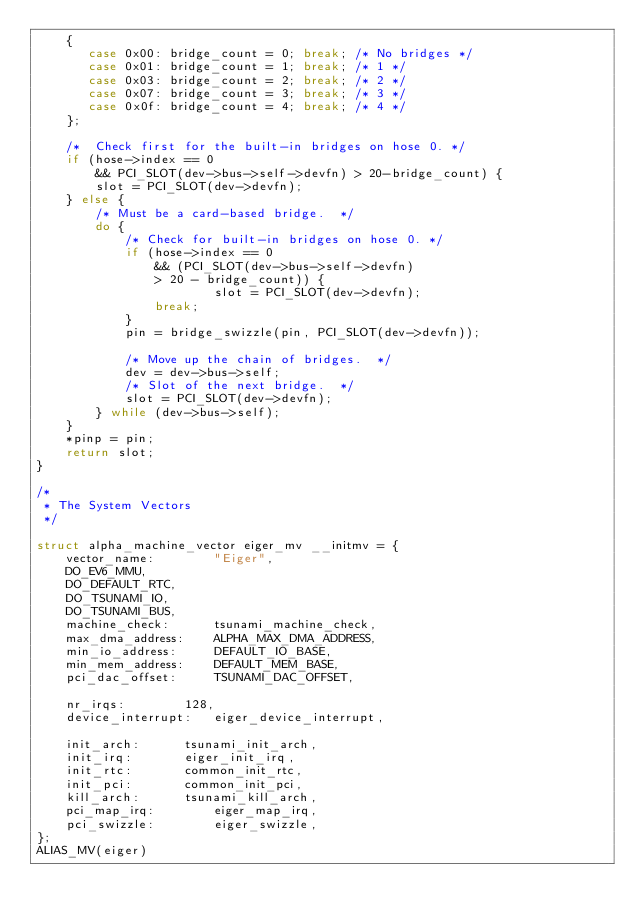Convert code to text. <code><loc_0><loc_0><loc_500><loc_500><_C_>	{
	   case 0x00: bridge_count = 0; break; /* No bridges */
	   case 0x01: bridge_count = 1; break; /* 1 */
	   case 0x03: bridge_count = 2; break; /* 2 */
	   case 0x07: bridge_count = 3; break; /* 3 */
	   case 0x0f: bridge_count = 4; break; /* 4 */
	};

	/*  Check first for the built-in bridges on hose 0. */
	if (hose->index == 0
	    && PCI_SLOT(dev->bus->self->devfn) > 20-bridge_count) {
		slot = PCI_SLOT(dev->devfn);
	} else {
		/* Must be a card-based bridge.  */
		do {
			/* Check for built-in bridges on hose 0. */
			if (hose->index == 0
			    && (PCI_SLOT(dev->bus->self->devfn)
				> 20 - bridge_count)) {
                  		slot = PCI_SLOT(dev->devfn);
				break;
			}
			pin = bridge_swizzle(pin, PCI_SLOT(dev->devfn));

			/* Move up the chain of bridges.  */
			dev = dev->bus->self;
			/* Slot of the next bridge.  */
			slot = PCI_SLOT(dev->devfn);
		} while (dev->bus->self);
	}
	*pinp = pin;
	return slot;
}

/*
 * The System Vectors
 */

struct alpha_machine_vector eiger_mv __initmv = {
	vector_name:		"Eiger",
	DO_EV6_MMU,
	DO_DEFAULT_RTC,
	DO_TSUNAMI_IO,
	DO_TSUNAMI_BUS,
	machine_check:		tsunami_machine_check,
	max_dma_address:	ALPHA_MAX_DMA_ADDRESS,
	min_io_address:		DEFAULT_IO_BASE,
	min_mem_address:	DEFAULT_MEM_BASE,
	pci_dac_offset:		TSUNAMI_DAC_OFFSET,

	nr_irqs:		128,
	device_interrupt:	eiger_device_interrupt,

	init_arch:		tsunami_init_arch,
	init_irq:		eiger_init_irq,
	init_rtc:		common_init_rtc,
	init_pci:		common_init_pci,
	kill_arch:		tsunami_kill_arch,
	pci_map_irq:		eiger_map_irq,
	pci_swizzle:		eiger_swizzle,
};
ALIAS_MV(eiger)
</code> 